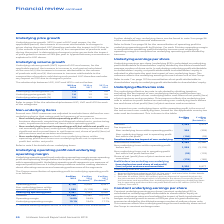According to Unilever Plc's financial document, What does the underlying operating profit represent?  Underlying operating profit represents our measure of segment profit or loss as it is the primary measure used for making decisions about allocating resources and assessing performance of the segments.. The document states: "t of non-underlying items within operating profit. Underlying operating profit represents our measure of segment profit or loss as it is the primary m..." Also, How is the operating margin computed? For each Division operating margin is computed as operating profit divided by turnover and underlying operating margin is computed as underlying operating profit divided by turnover.. The document states: "profit to underlying operating profit by Division. For each Division operating margin is computed as operating profit divided by turnover and underlyi..." Also, What is the definition of the Underlying operating profit and underlying operating margin? Underlying operating profit and underlying operating margin mean operating profit and operating margin before the impact of non-underlying items within operating profit.. The document states: "Underlying operating profit and underlying operating margin mean operating profit and operating margin before the impact of non-underlying items withi..." Also, can you calculate: What is the increase / (decrease) in the operating profit from 2018 to 2019? Based on the calculation: 8,708 - 12,639, the result is -3931 (in millions). This is based on the information: "Operating profit 8,708 12,639 8,957 Non-underlying items within operating profit (see note 3) 1,239 (3,176) 543 Operating profit 8,708 12,639 8,957 Non-underlying items within operating profit (see no..." The key data points involved are: 12,639, 8,708. Also, can you calculate: What is the increase / (decrease) in the operating margin from 2018 to 2019? Based on the calculation: 16.8 - 24.8, the result is -8 (percentage). This is based on the information: "Operating margin 16.8% 24.8% 16.7% Operating margin 16.8% 24.8% 16.7%..." The key data points involved are: 16.8, 24.8. Also, can you calculate: What is the average turnover? To answer this question, I need to perform calculations using the financial data. The calculation is: (51,980 + 50,982 + 53,715) / 3, which equals 52225.67 (in millions). This is based on the information: "Turnover 51,980 50,982 53,715 Turnover 51,980 50,982 53,715 Turnover 51,980 50,982 53,715..." The key data points involved are: 50,982, 51,980, 53,715. 